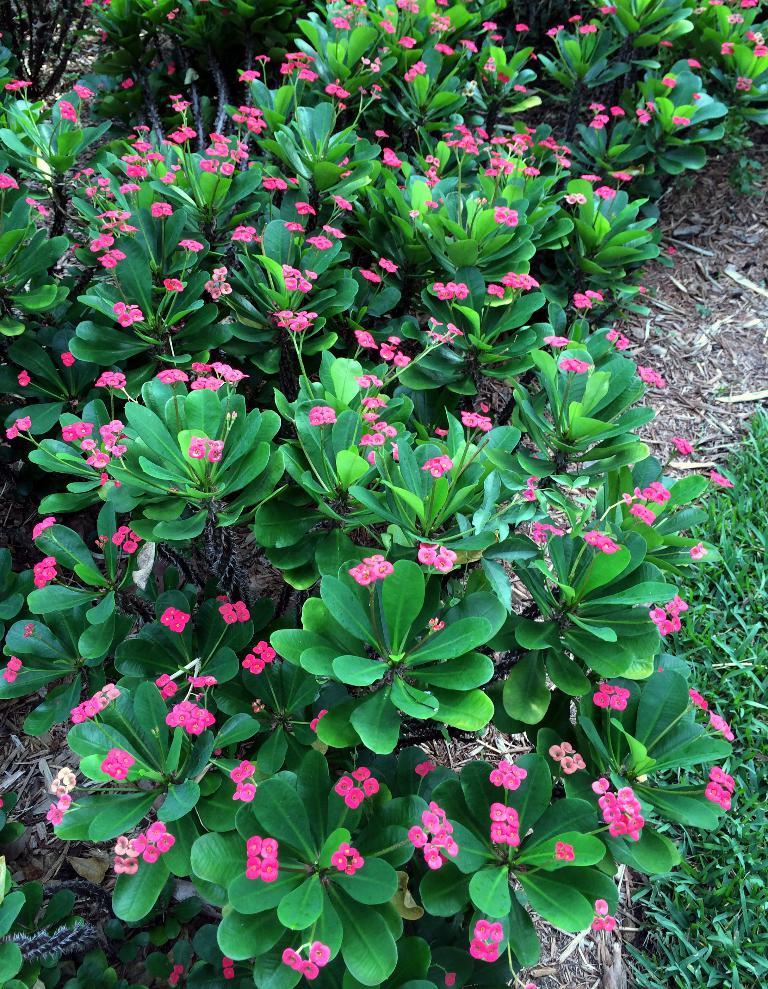What type of living organisms can be seen in the image? Plants can be seen in the image. What are the plants producing? There are flowers associated with the plants. What type of playground equipment can be seen in the image? There is no playground equipment present in the image; it features plants and flowers. What nerve is responsible for controlling the movement of the flowers in the image? There are no nerves or movement associated with the flowers in the image; they are stationary. 